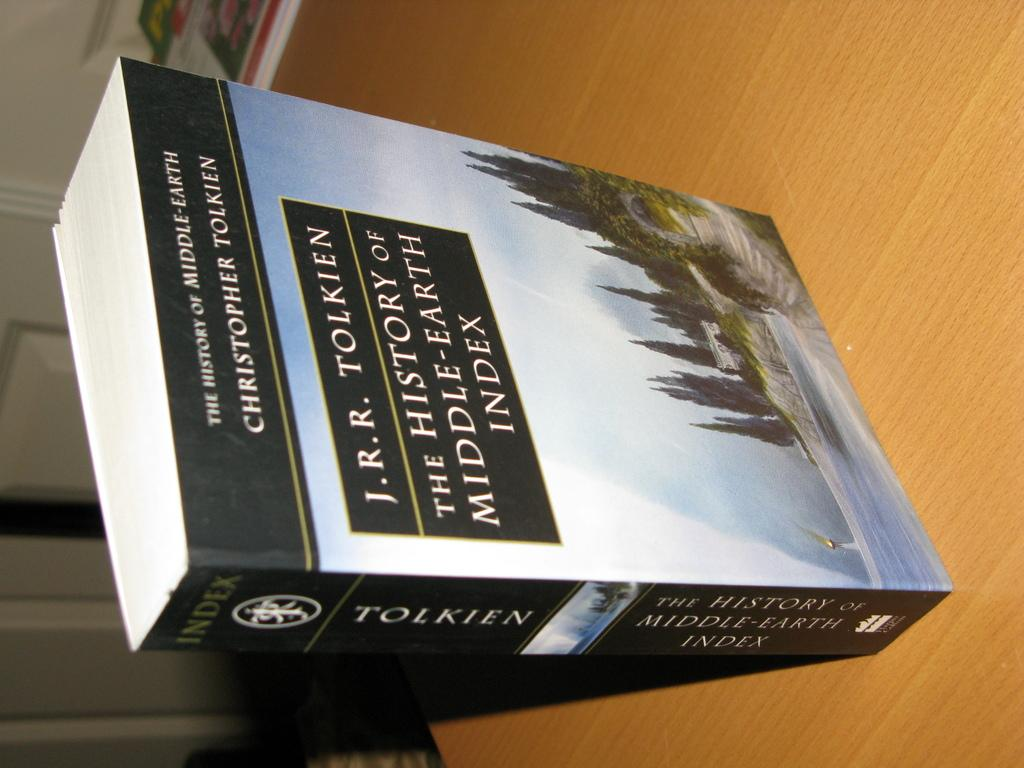<image>
Offer a succinct explanation of the picture presented. A book by J.R.R Tokien sits upright on a wooden table 